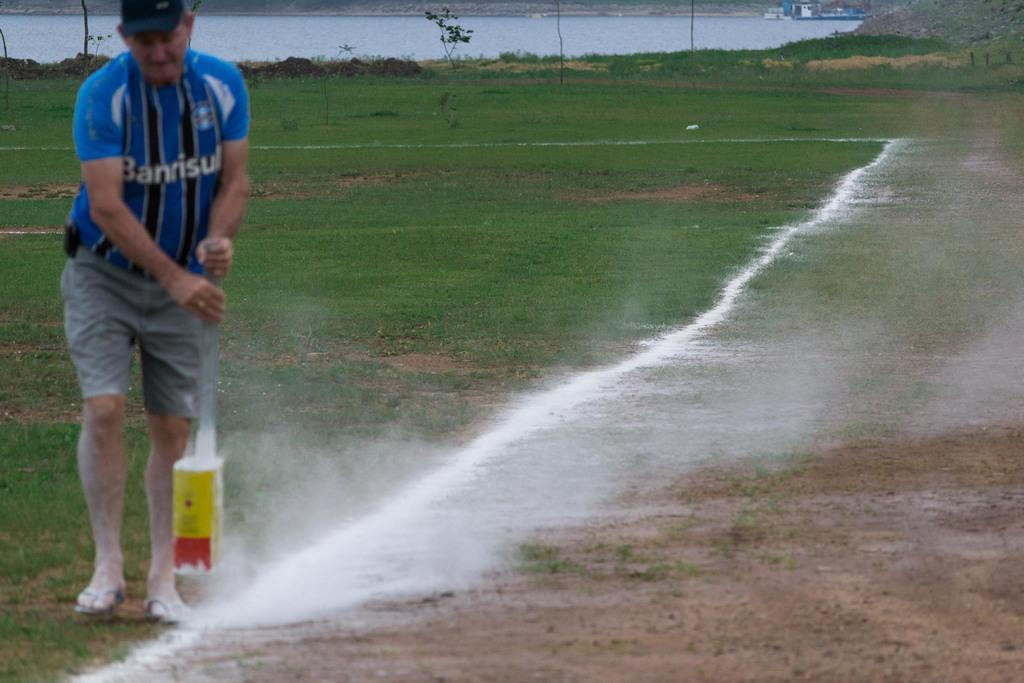<image>
Write a terse but informative summary of the picture. Man wearing a blue BANRISU shirt spraying something on the ground. 